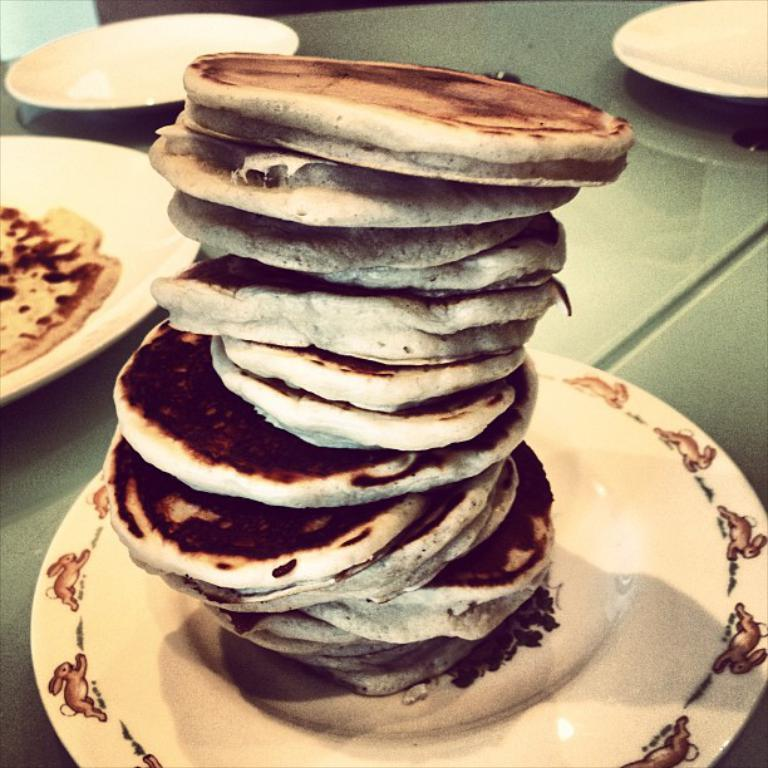What is on the white plate in the image? There are food items on a white plate in the image. Where is the white plate located? The white plate is on a table. How many other white plates are on the table? There are three other white plates on the table. What type of disgust can be seen on the faces of the people in the image? There are no people present in the image, so it is not possible to determine their facial expressions or emotions. 